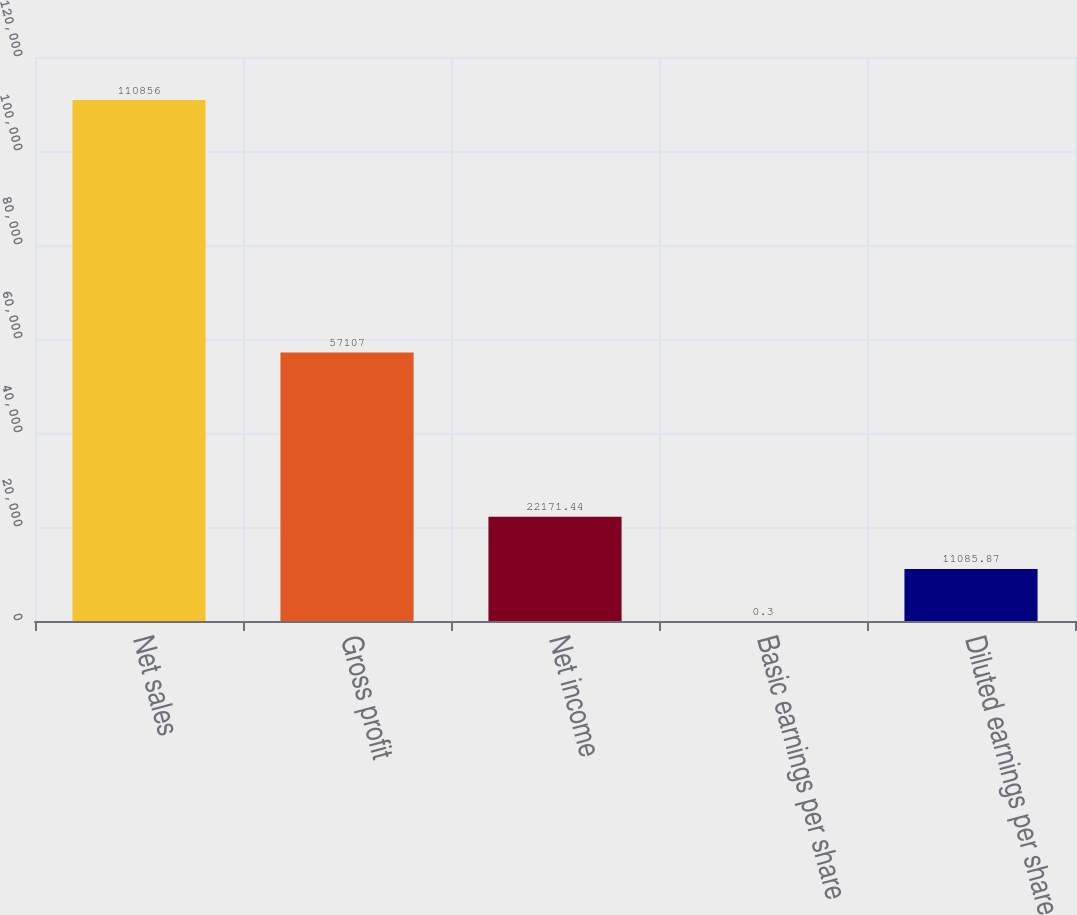Convert chart. <chart><loc_0><loc_0><loc_500><loc_500><bar_chart><fcel>Net sales<fcel>Gross profit<fcel>Net income<fcel>Basic earnings per share<fcel>Diluted earnings per share<nl><fcel>110856<fcel>57107<fcel>22171.4<fcel>0.3<fcel>11085.9<nl></chart> 